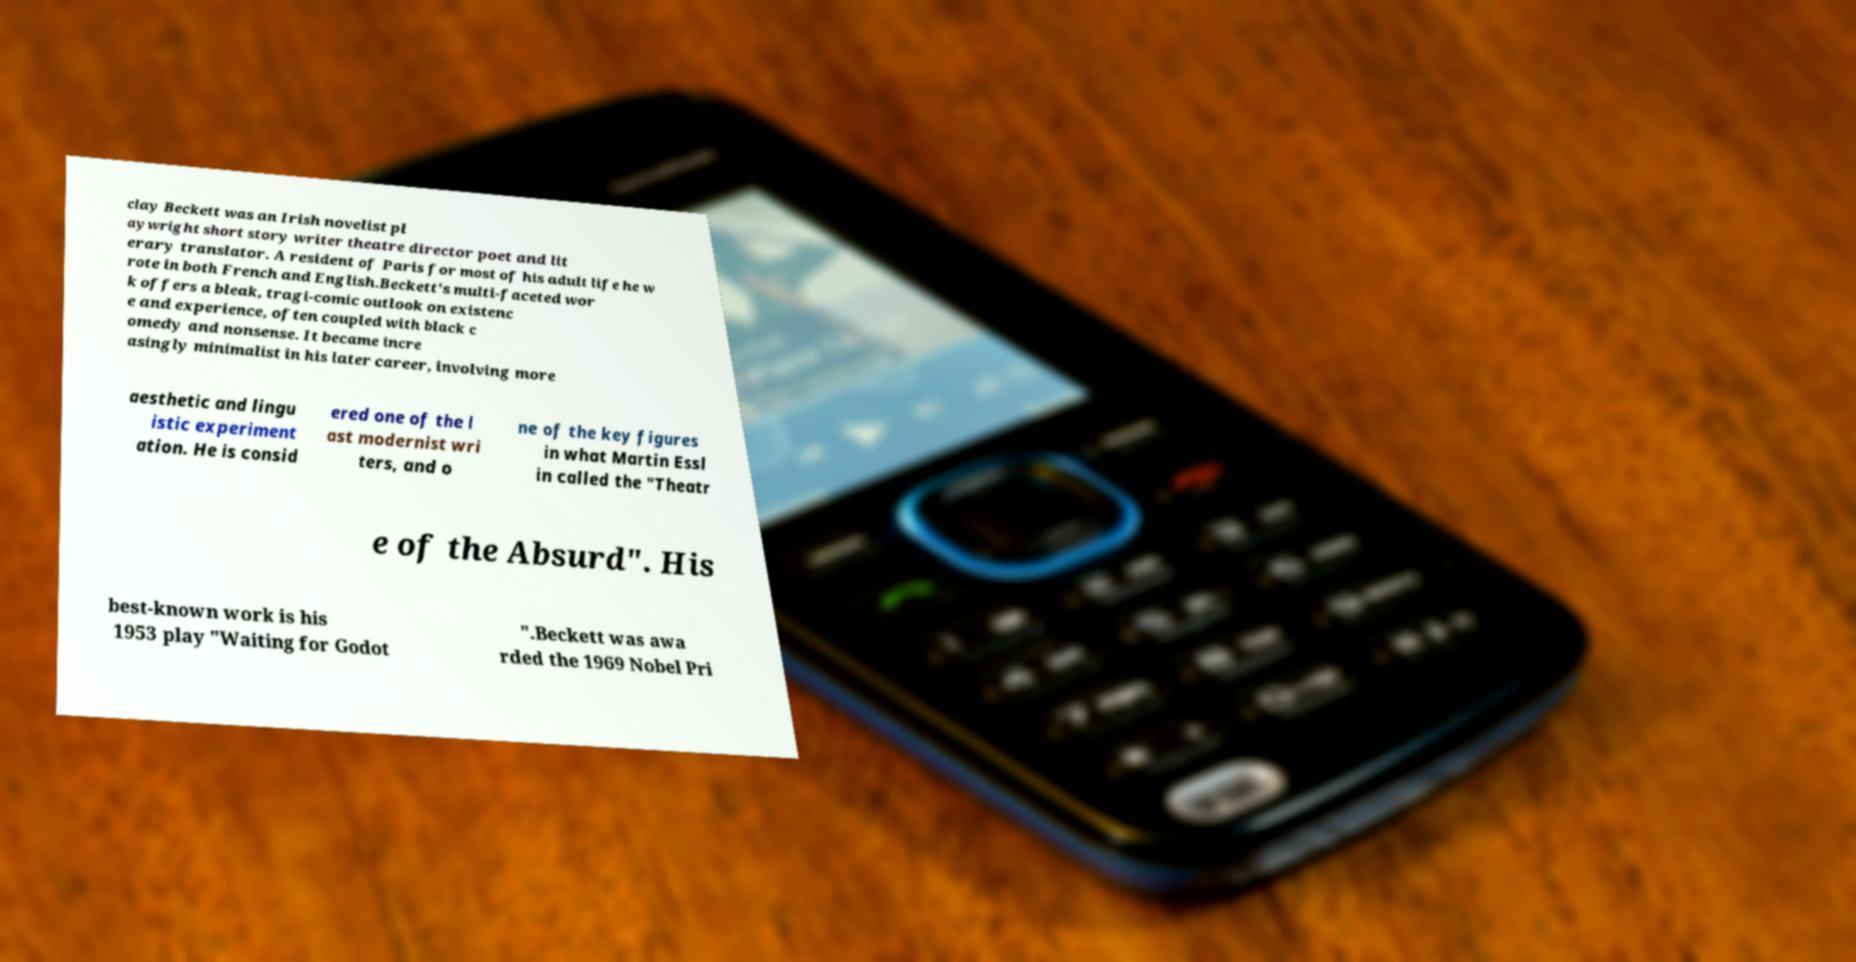Can you read and provide the text displayed in the image?This photo seems to have some interesting text. Can you extract and type it out for me? clay Beckett was an Irish novelist pl aywright short story writer theatre director poet and lit erary translator. A resident of Paris for most of his adult life he w rote in both French and English.Beckett's multi-faceted wor k offers a bleak, tragi-comic outlook on existenc e and experience, often coupled with black c omedy and nonsense. It became incre asingly minimalist in his later career, involving more aesthetic and lingu istic experiment ation. He is consid ered one of the l ast modernist wri ters, and o ne of the key figures in what Martin Essl in called the "Theatr e of the Absurd". His best-known work is his 1953 play "Waiting for Godot ".Beckett was awa rded the 1969 Nobel Pri 